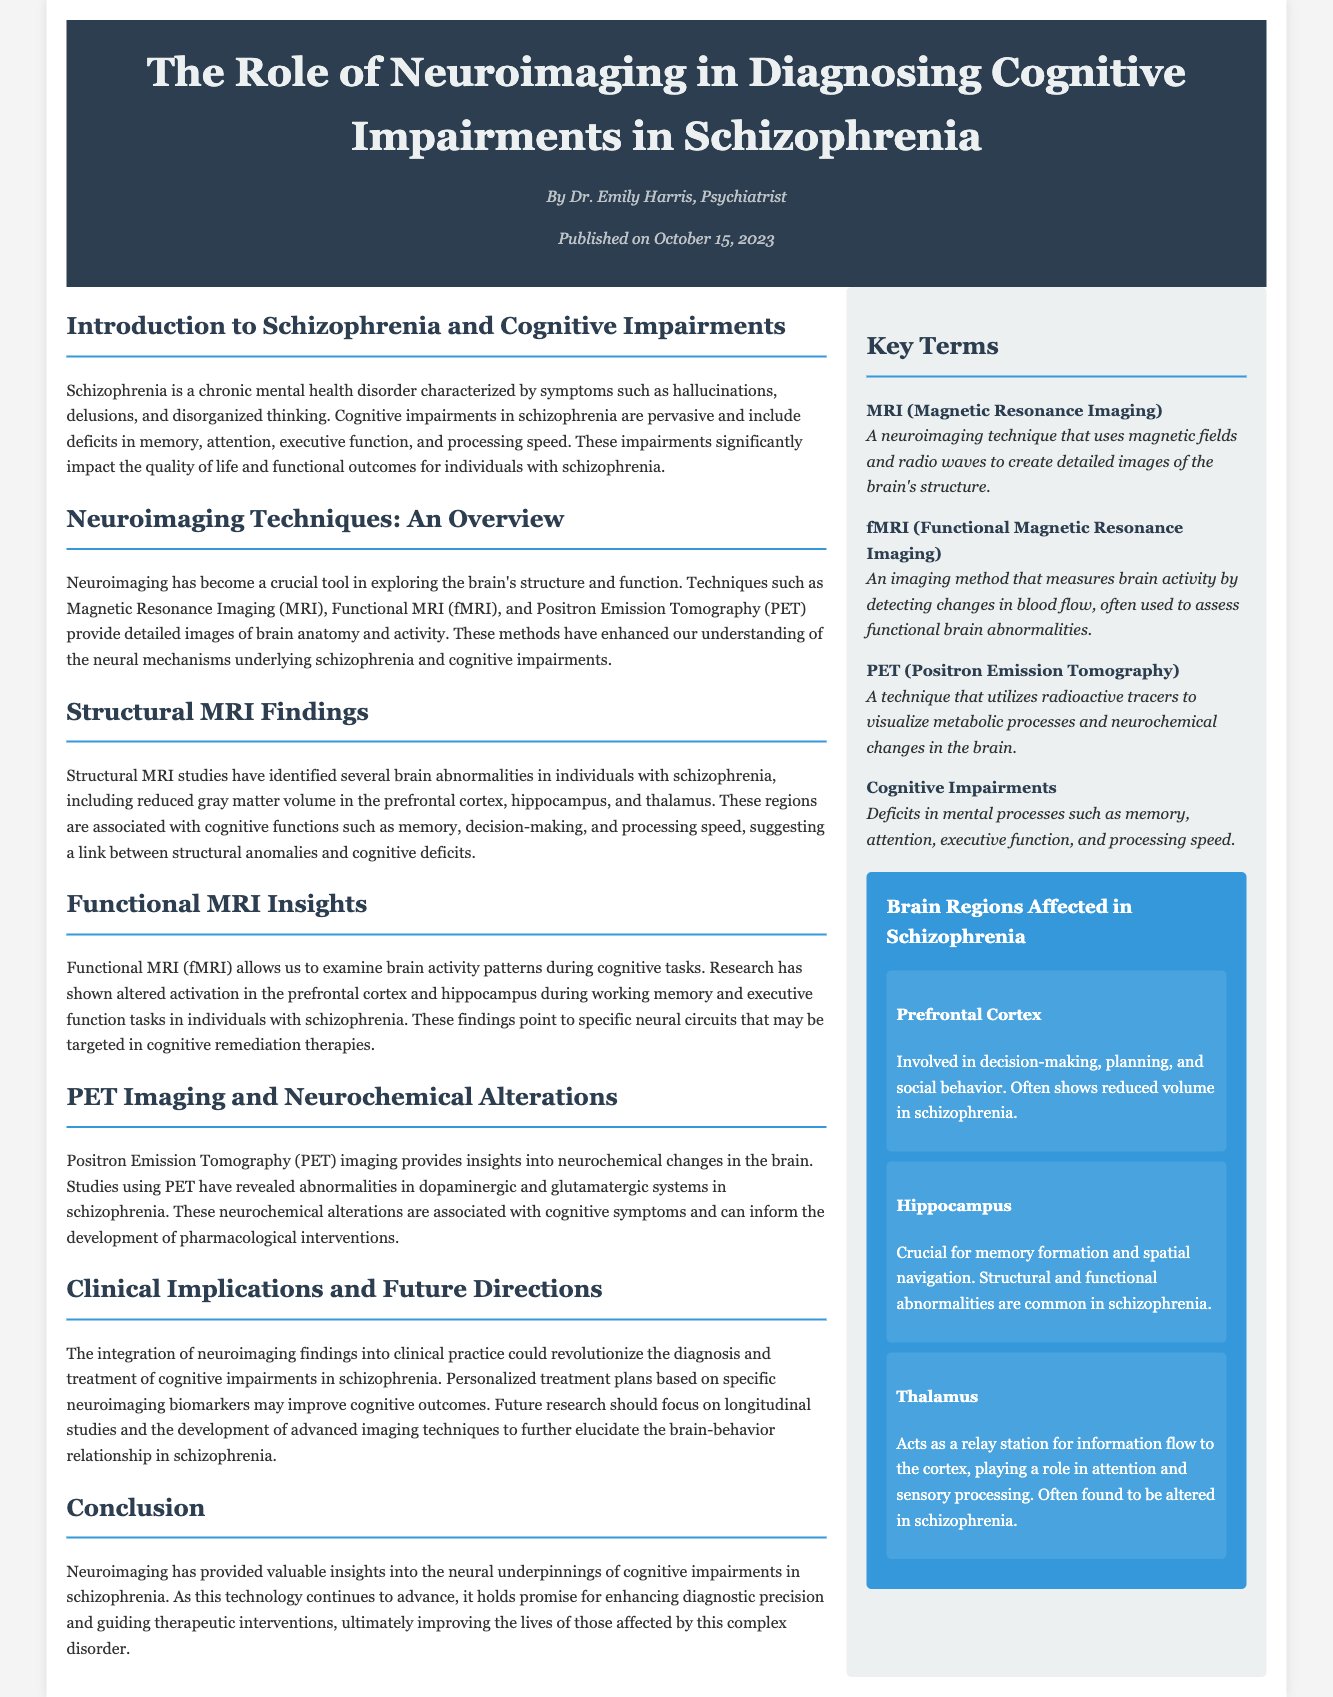What is the title of the article? The title of the article is presented in the header of the document.
Answer: The Role of Neuroimaging in Diagnosing Cognitive Impairments in Schizophrenia Who is the author of the article? The author is mentioned below the title in the header.
Answer: Dr. Emily Harris What date was the article published? The publication date is also provided in the header along with the author name.
Answer: October 15, 2023 Which neuroimaging technique uses radioactive tracers? The specific neuroimaging method is detailed in the key terms section of the document.
Answer: PET (Positron Emission Tomography) What brain region is involved in decision-making? This brain region is mentioned in the infographic section discussing brain regions affected in schizophrenia.
Answer: Prefrontal Cortex What type of MRI allows examination of brain activity patterns? This type of MRI is highlighted in the section discussing neuroimaging techniques.
Answer: fMRI (Functional Magnetic Resonance Imaging) Which cognitive function is primarily associated with the hippocampus? The document states the role of the hippocampus in the context of cognitive impairments.
Answer: Memory formation How many brain regions are mentioned in the infographic? The number of brain regions is indicated by the entries listed in the infographic section.
Answer: Three What is the main conclusion of the article? The conclusion summarizes the significance of neuroimaging in understanding cognitive impairments in schizophrenia.
Answer: Neuroimaging has provided valuable insights into the neural underpinnings of cognitive impairments in schizophrenia 